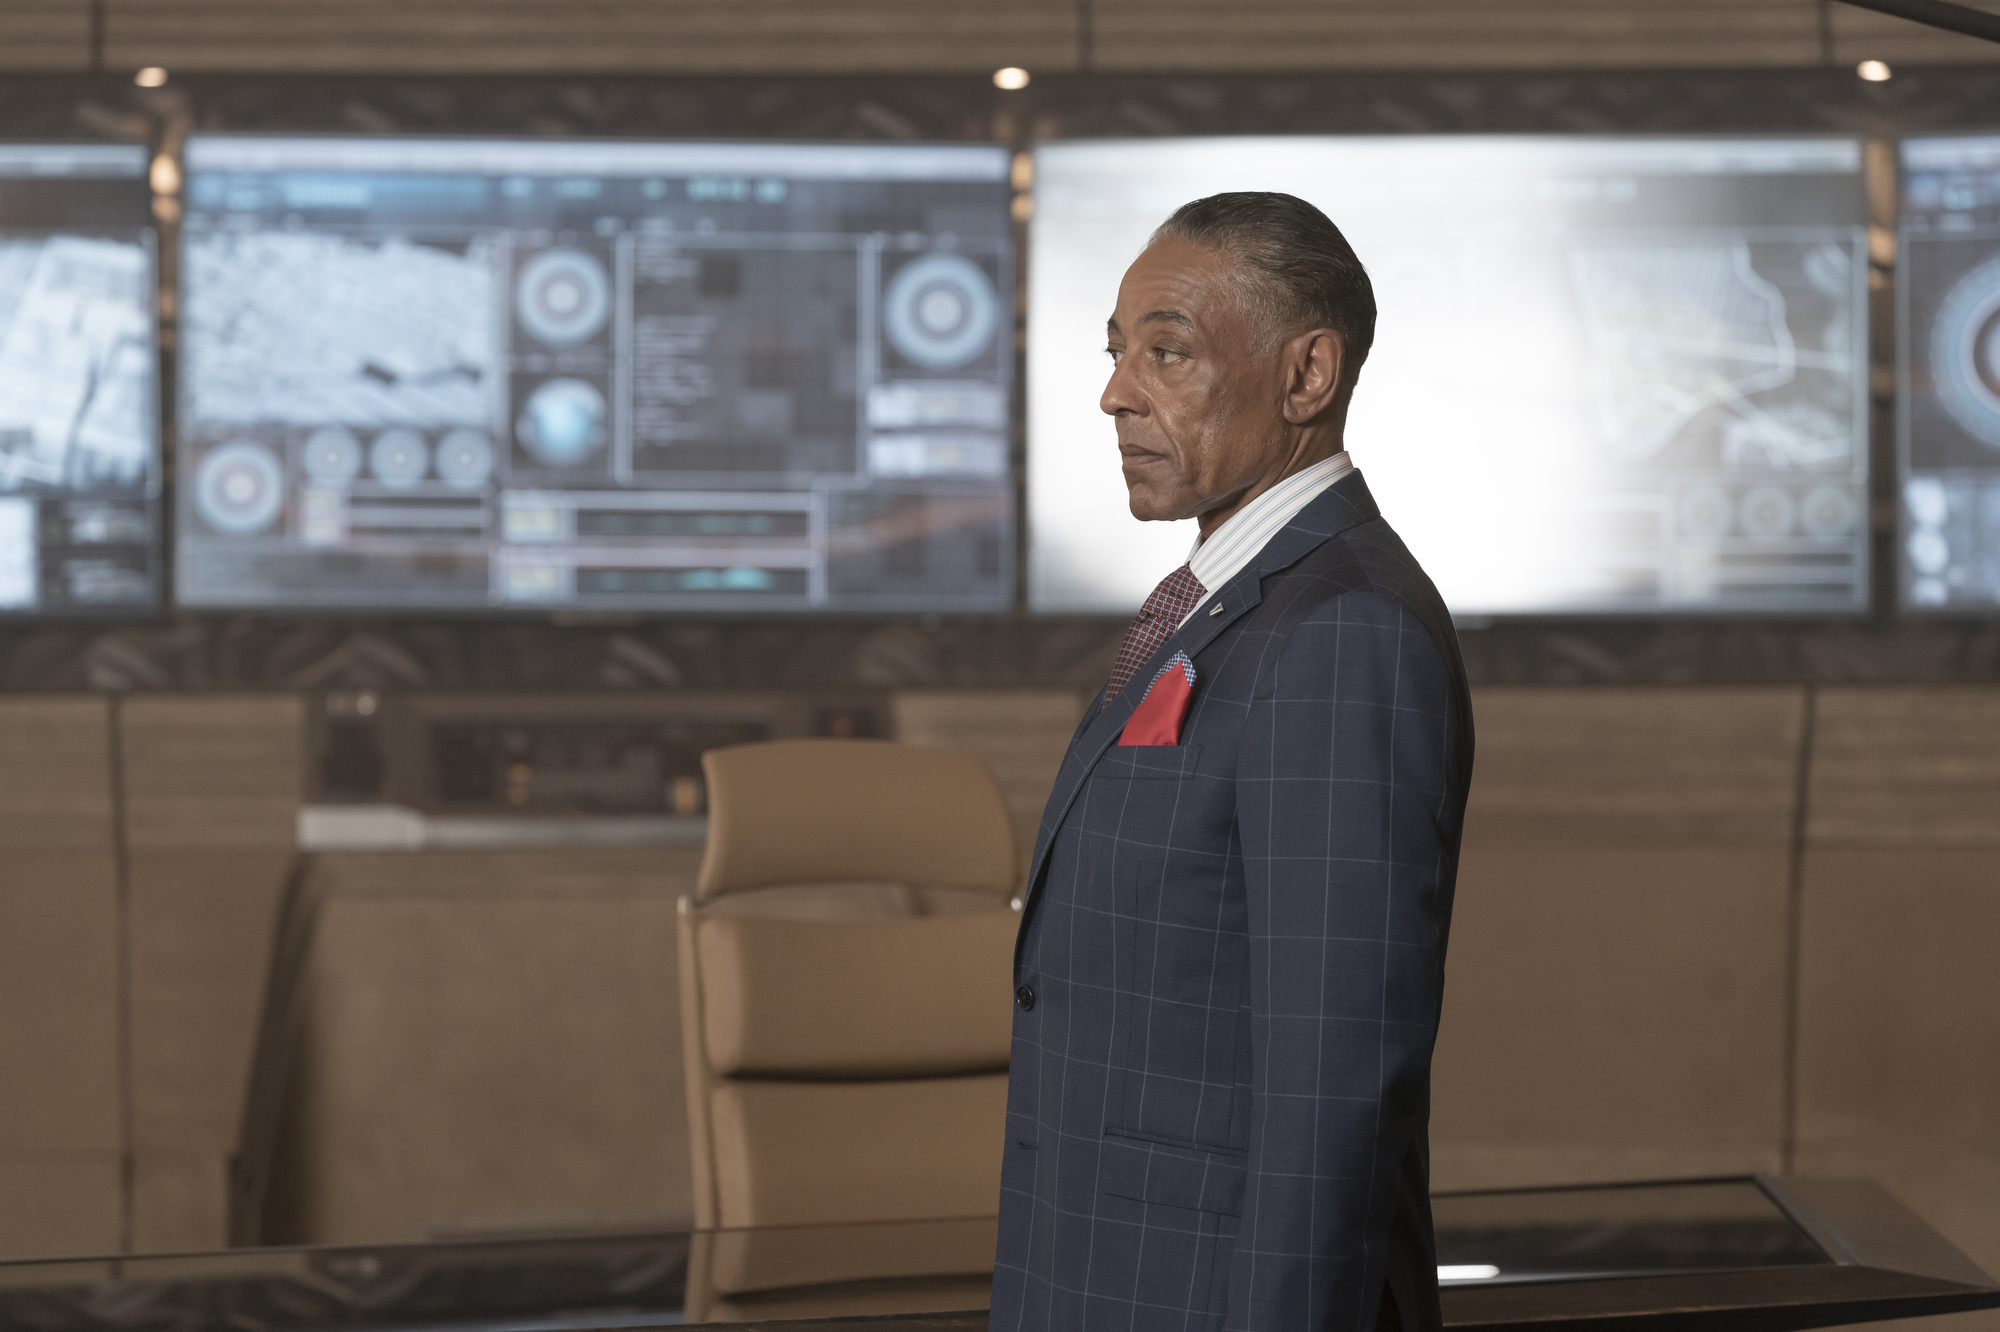What kind of technology might be monitored on the screens behind the man? The screens behind the man are likely displaying data related to security monitoring or advanced analytics. This could include live satellite imagery, weather patterns, or possibly strategic data relevant to national or corporate security measures. 